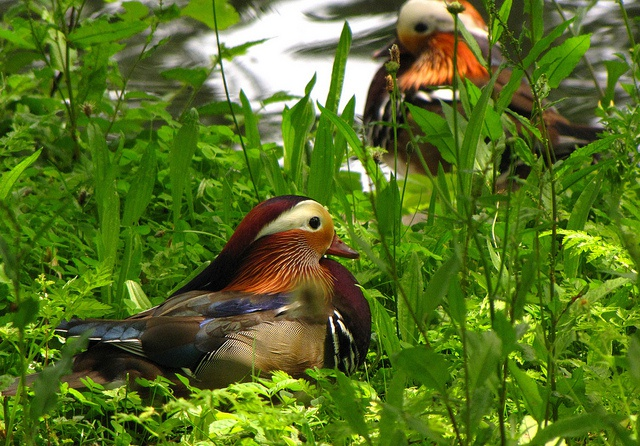Describe the objects in this image and their specific colors. I can see bird in gray, black, olive, maroon, and darkgreen tones and bird in gray, black, darkgreen, and green tones in this image. 